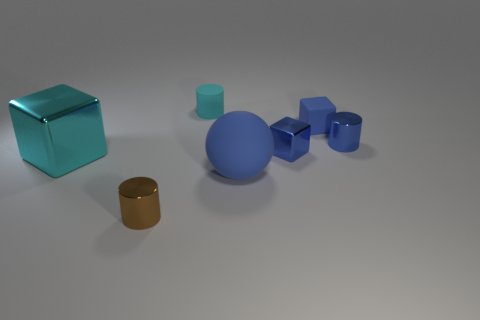Subtract all tiny blue blocks. How many blocks are left? 1 Add 1 blue metal objects. How many objects exist? 8 Subtract all balls. How many objects are left? 6 Subtract all brown spheres. How many blue cubes are left? 2 Subtract all cyan blocks. How many blocks are left? 2 Subtract all green blocks. Subtract all red spheres. How many blocks are left? 3 Subtract all cylinders. Subtract all tiny brown cylinders. How many objects are left? 3 Add 3 blue metallic cylinders. How many blue metallic cylinders are left? 4 Add 6 purple matte cylinders. How many purple matte cylinders exist? 6 Subtract 0 cyan balls. How many objects are left? 7 